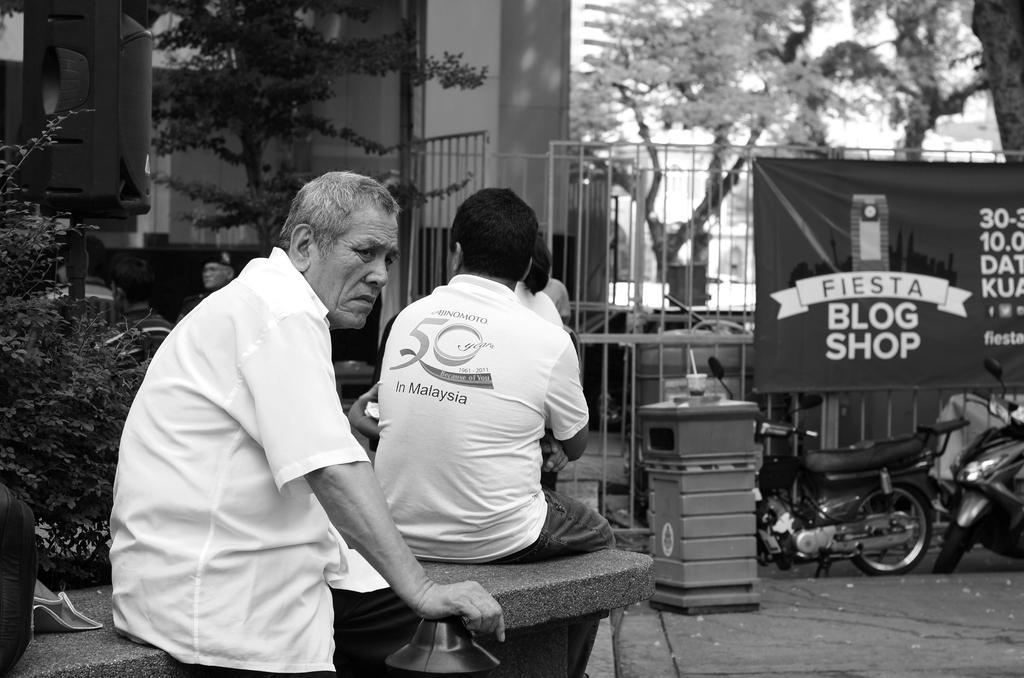Can you describe this image briefly? In this picture there are group of people sitting. At the back there are buildings and trees and there is a banner on the railing and there is text on the banner and there are vehicles. At the top there is sky. At the bottom there is a floor. On the left side of the image there is a speaker. 